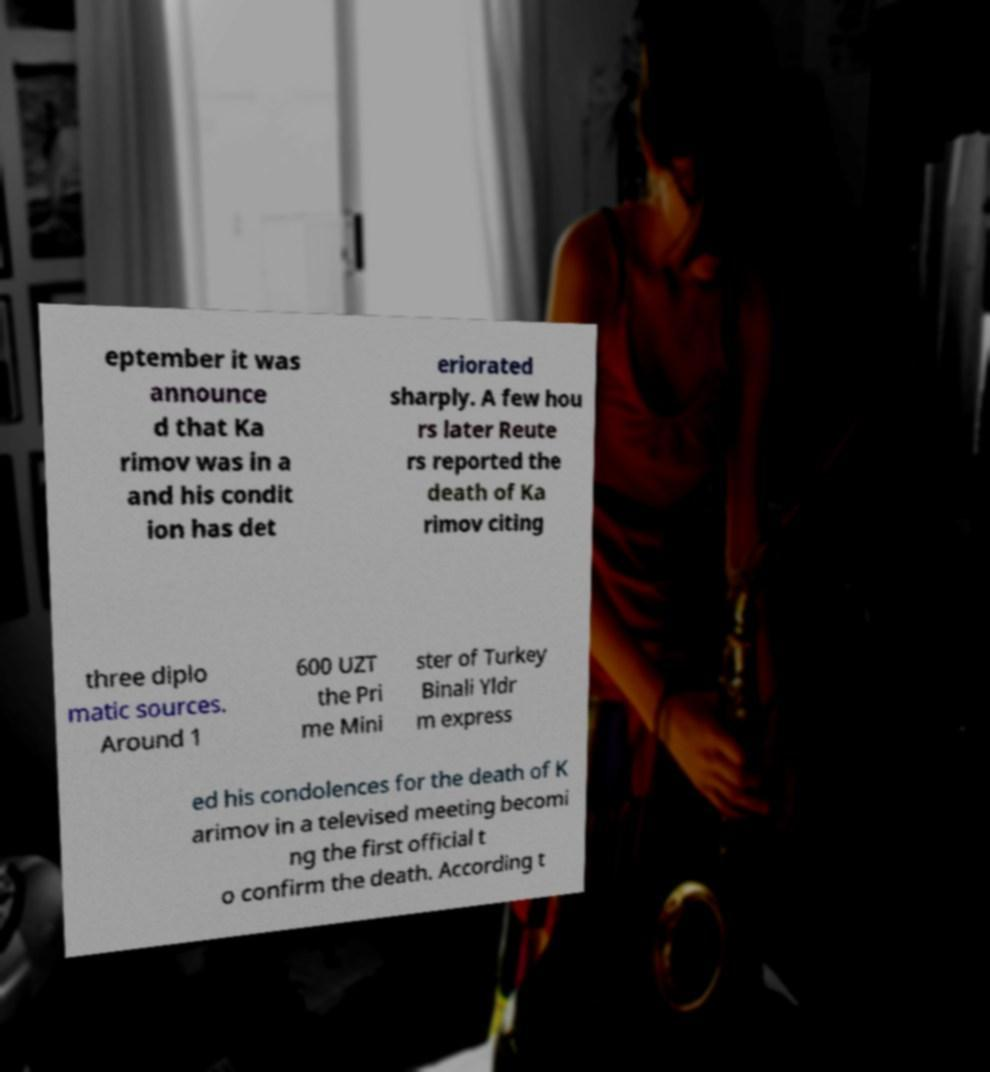I need the written content from this picture converted into text. Can you do that? eptember it was announce d that Ka rimov was in a and his condit ion has det eriorated sharply. A few hou rs later Reute rs reported the death of Ka rimov citing three diplo matic sources. Around 1 600 UZT the Pri me Mini ster of Turkey Binali Yldr m express ed his condolences for the death of K arimov in a televised meeting becomi ng the first official t o confirm the death. According t 